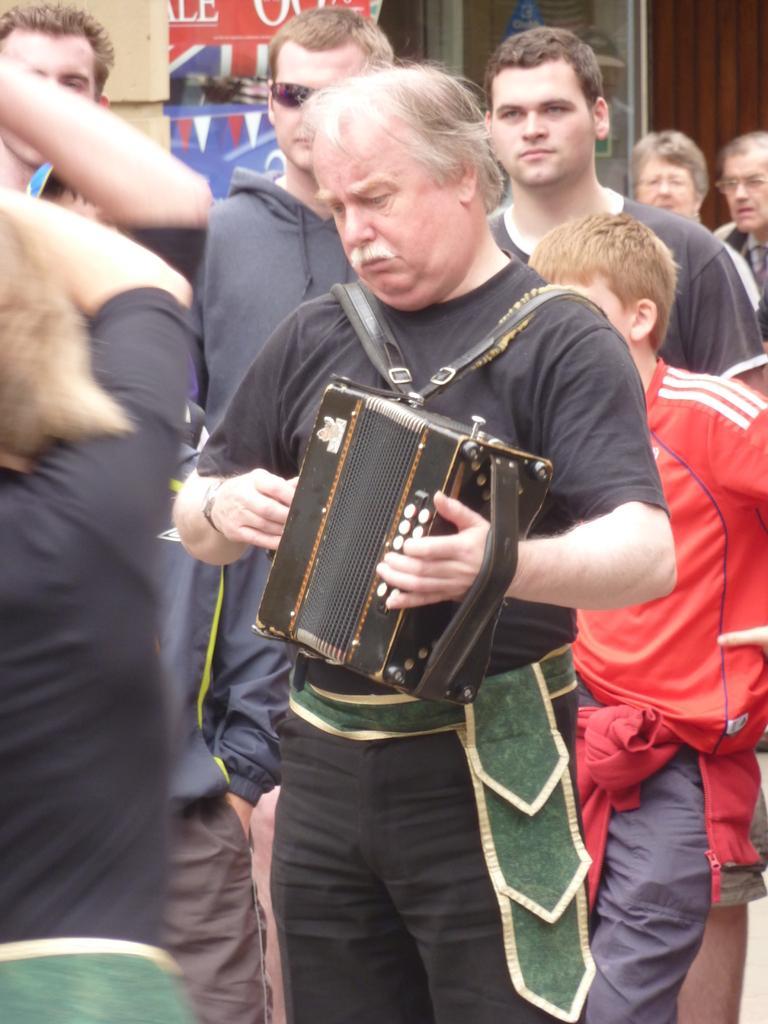Please provide a concise description of this image. In this picture we can see a group of people and one person is holding a musical instrument and in the background we can see a poster and some objects. 